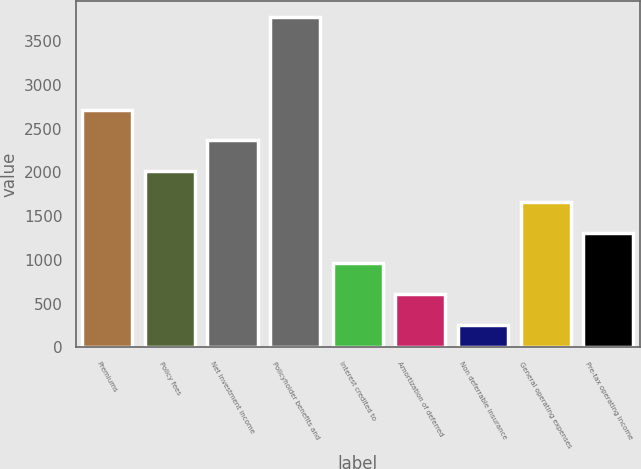Convert chart to OTSL. <chart><loc_0><loc_0><loc_500><loc_500><bar_chart><fcel>Premiums<fcel>Policy fees<fcel>Net investment income<fcel>Policyholder benefits and<fcel>Interest credited to<fcel>Amortization of deferred<fcel>Non deferrable insurance<fcel>General operating expenses<fcel>Pre-tax operating income<nl><fcel>2716.8<fcel>2014<fcel>2365.4<fcel>3771<fcel>959.8<fcel>608.4<fcel>257<fcel>1662.6<fcel>1311.2<nl></chart> 